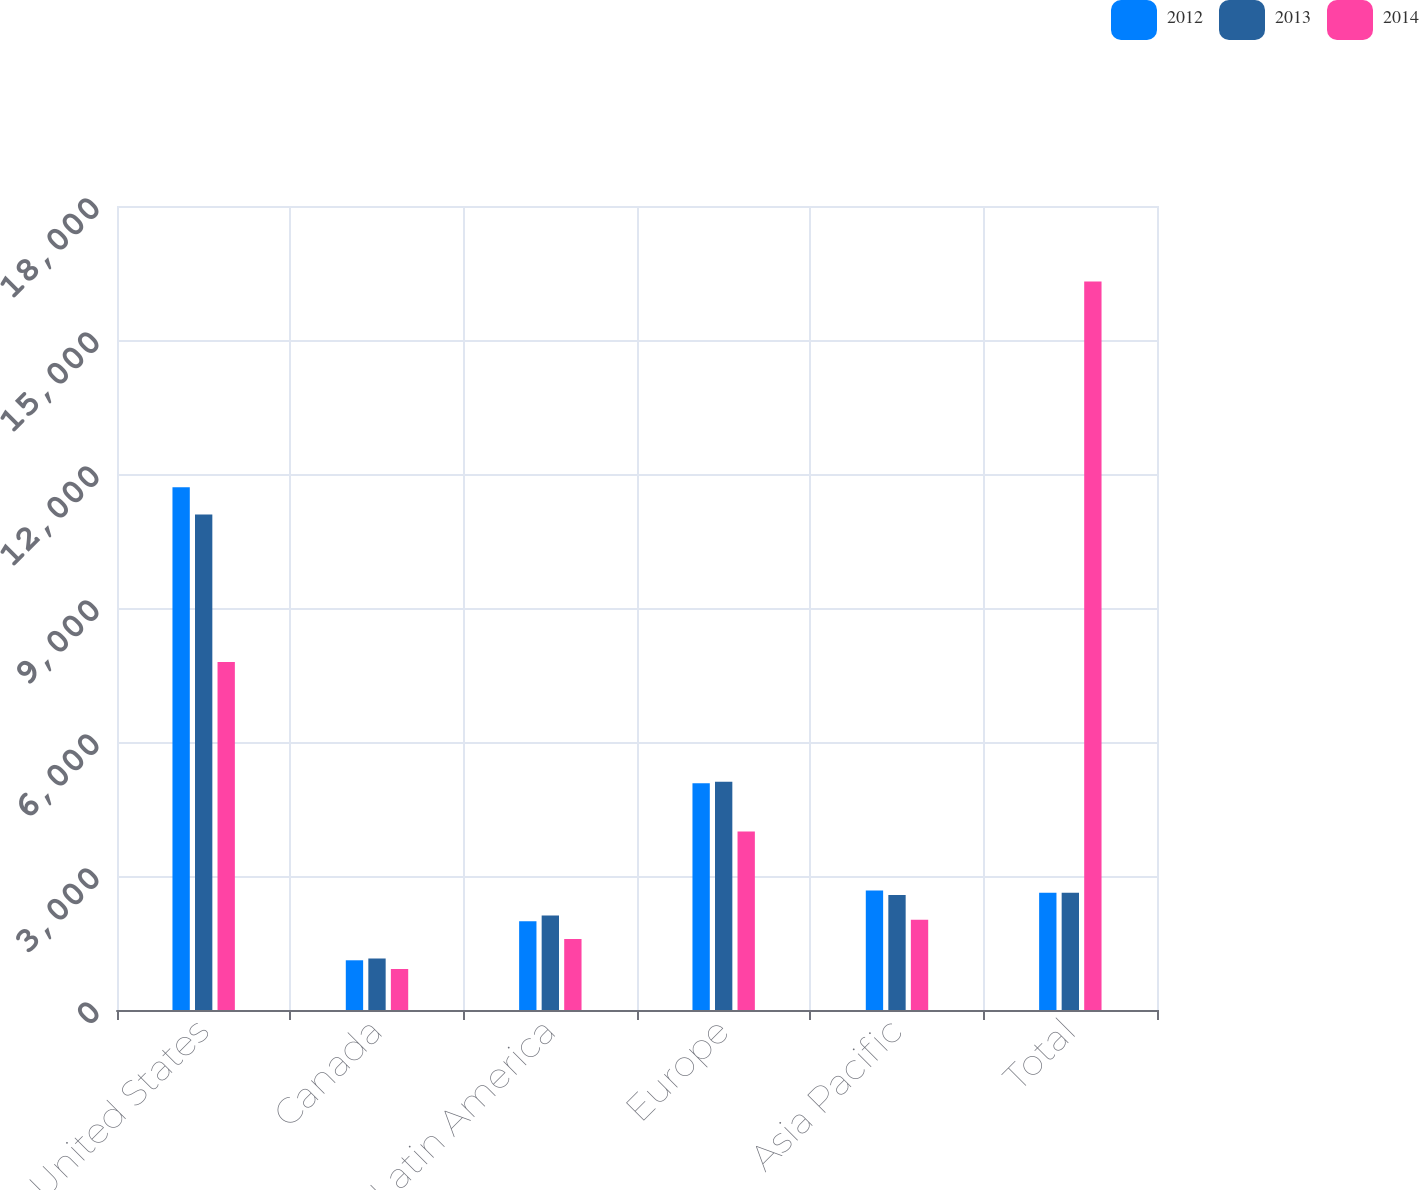Convert chart to OTSL. <chart><loc_0><loc_0><loc_500><loc_500><stacked_bar_chart><ecel><fcel>United States<fcel>Canada<fcel>Latin America<fcel>Europe<fcel>Asia Pacific<fcel>Total<nl><fcel>2012<fcel>11701<fcel>1113<fcel>1988<fcel>5074<fcel>2676<fcel>2625.5<nl><fcel>2013<fcel>11092<fcel>1154<fcel>2113<fcel>5112<fcel>2575<fcel>2625.5<nl><fcel>2014<fcel>7789<fcel>918<fcel>1588<fcel>3997<fcel>2019<fcel>16311<nl></chart> 